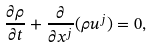<formula> <loc_0><loc_0><loc_500><loc_500>\frac { \partial \rho } { \partial t } + \frac { \partial } { \partial x ^ { j } } ( \rho u ^ { j } ) = 0 ,</formula> 